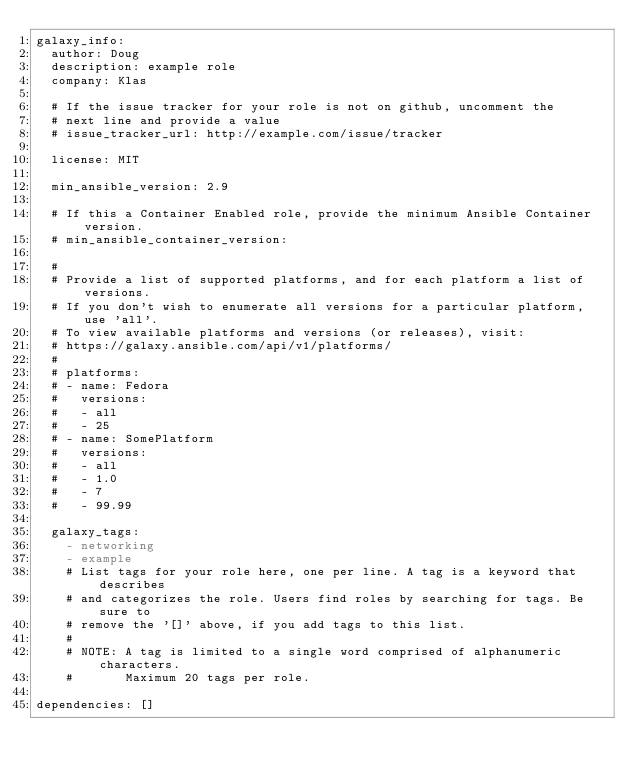<code> <loc_0><loc_0><loc_500><loc_500><_YAML_>galaxy_info:
  author: Doug
  description: example role
  company: Klas

  # If the issue tracker for your role is not on github, uncomment the
  # next line and provide a value
  # issue_tracker_url: http://example.com/issue/tracker

  license: MIT

  min_ansible_version: 2.9

  # If this a Container Enabled role, provide the minimum Ansible Container version.
  # min_ansible_container_version:

  #
  # Provide a list of supported platforms, and for each platform a list of versions.
  # If you don't wish to enumerate all versions for a particular platform, use 'all'.
  # To view available platforms and versions (or releases), visit:
  # https://galaxy.ansible.com/api/v1/platforms/
  #
  # platforms:
  # - name: Fedora
  #   versions:
  #   - all
  #   - 25
  # - name: SomePlatform
  #   versions:
  #   - all
  #   - 1.0
  #   - 7
  #   - 99.99

  galaxy_tags:
    - networking
    - example
    # List tags for your role here, one per line. A tag is a keyword that describes
    # and categorizes the role. Users find roles by searching for tags. Be sure to
    # remove the '[]' above, if you add tags to this list.
    #
    # NOTE: A tag is limited to a single word comprised of alphanumeric characters.
    #       Maximum 20 tags per role.

dependencies: []
</code> 